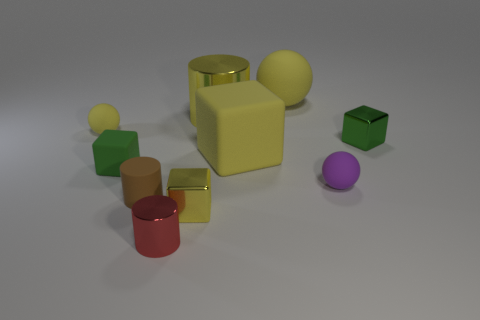There is a brown thing that is the same size as the purple sphere; what is its shape?
Keep it short and to the point. Cylinder. What number of tiny cubes are both on the left side of the purple matte object and behind the tiny brown thing?
Your response must be concise. 1. There is a green cube that is to the right of the tiny purple object; what is its material?
Provide a succinct answer. Metal. What size is the brown cylinder that is made of the same material as the small purple object?
Your answer should be very brief. Small. Does the rubber thing in front of the purple matte object have the same size as the cube to the right of the big rubber block?
Give a very brief answer. Yes. There is a red cylinder that is the same size as the purple rubber object; what is its material?
Your response must be concise. Metal. The sphere that is both on the right side of the small matte block and left of the small purple ball is made of what material?
Your response must be concise. Rubber. Is there a rubber cylinder?
Ensure brevity in your answer.  Yes. Do the big ball and the shiny cylinder behind the small yellow ball have the same color?
Provide a succinct answer. Yes. What material is the large ball that is the same color as the large rubber block?
Make the answer very short. Rubber. 